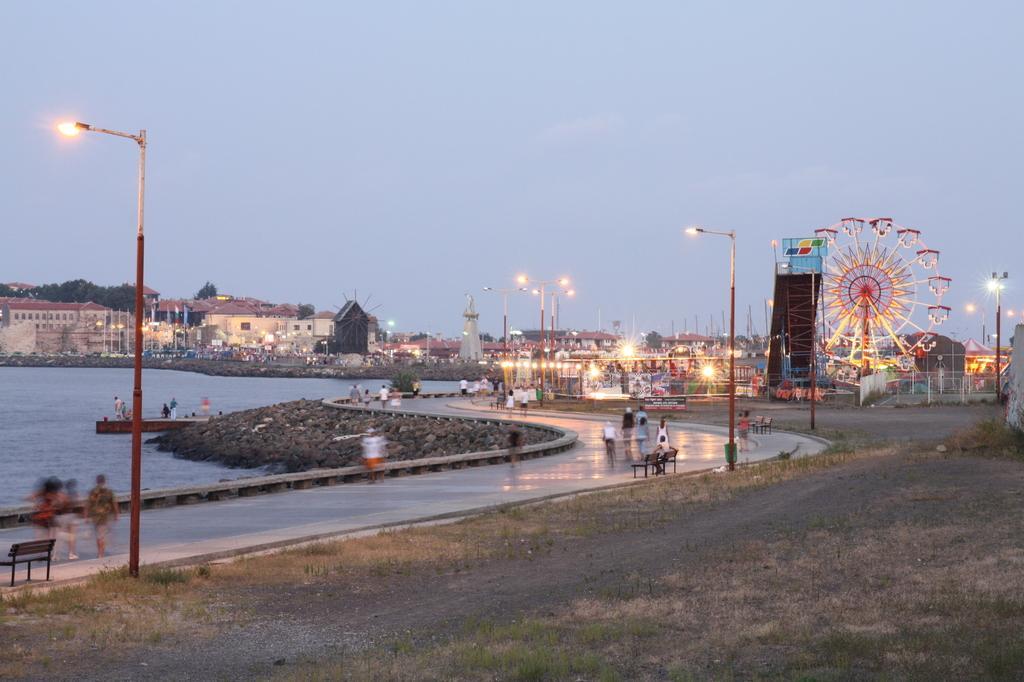Can you describe this image briefly? In this picture we can see poles, lights, buildings, trees, joint wheel, benches and some people on the road, water and in the background we can see the sky. 